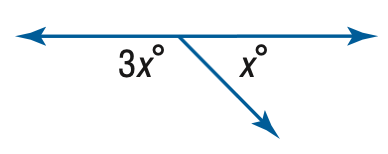Answer the mathemtical geometry problem and directly provide the correct option letter.
Question: Find x.
Choices: A: 45 B: 60 C: 90 D: 135 A 